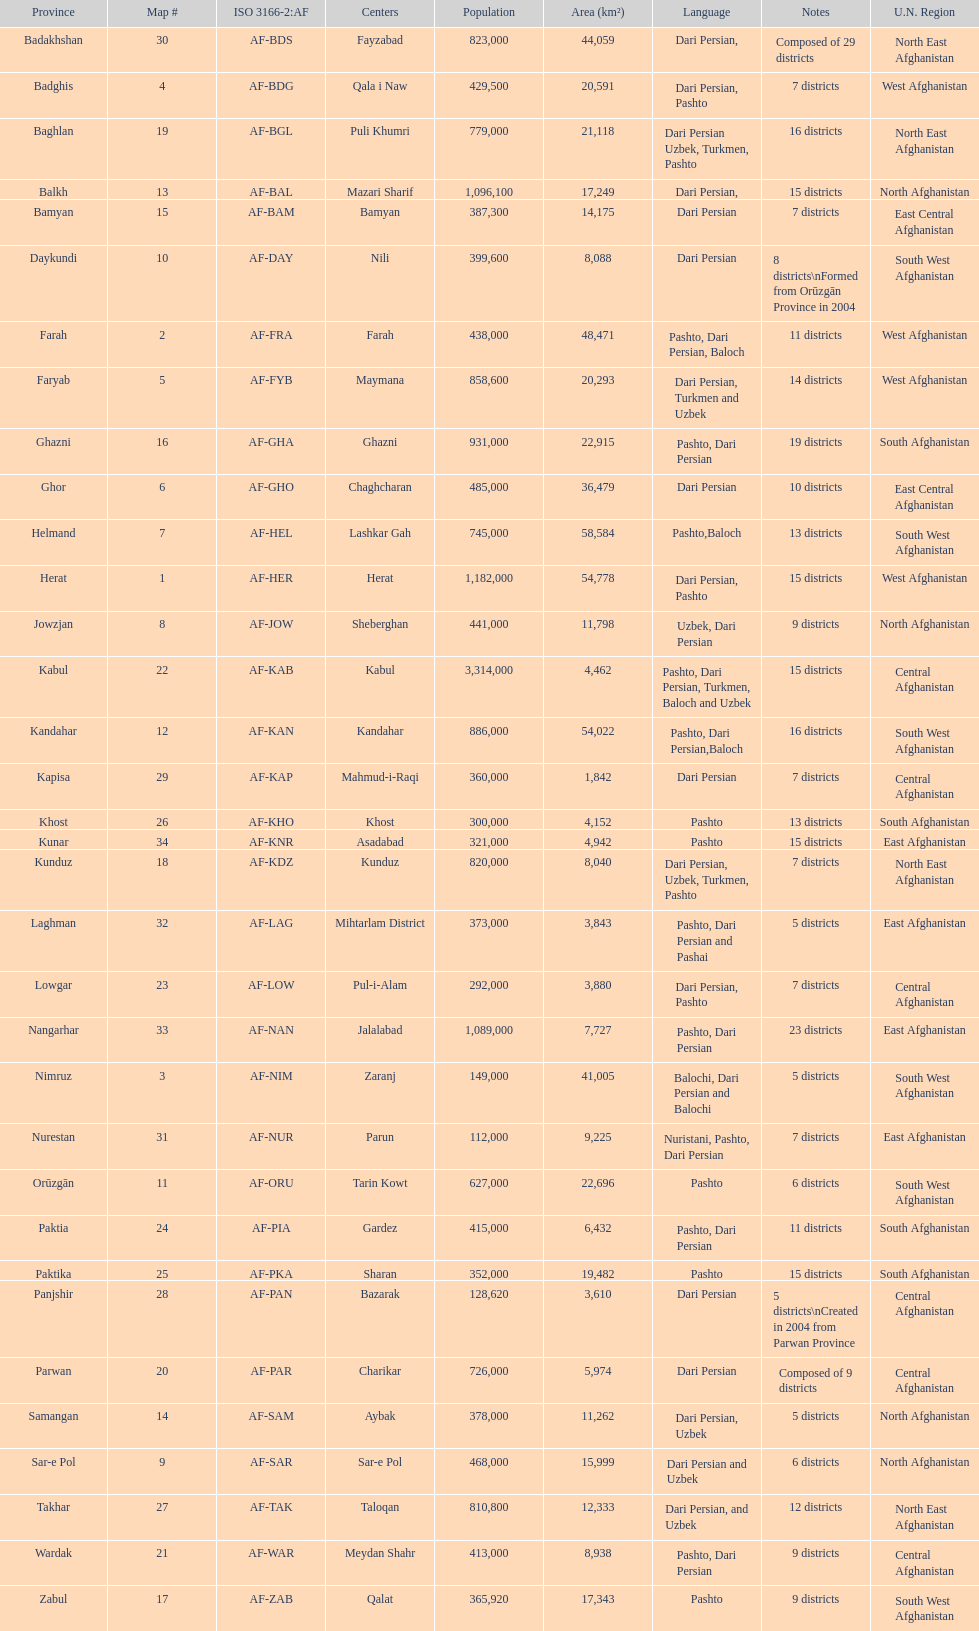How many provinces have the same number of districts as kabul? 4. Parse the table in full. {'header': ['Province', 'Map #', 'ISO 3166-2:AF', 'Centers', 'Population', 'Area (km²)', 'Language', 'Notes', 'U.N. Region'], 'rows': [['Badakhshan', '30', 'AF-BDS', 'Fayzabad', '823,000', '44,059', 'Dari Persian,', 'Composed of 29 districts', 'North East Afghanistan'], ['Badghis', '4', 'AF-BDG', 'Qala i Naw', '429,500', '20,591', 'Dari Persian, Pashto', '7 districts', 'West Afghanistan'], ['Baghlan', '19', 'AF-BGL', 'Puli Khumri', '779,000', '21,118', 'Dari Persian Uzbek, Turkmen, Pashto', '16 districts', 'North East Afghanistan'], ['Balkh', '13', 'AF-BAL', 'Mazari Sharif', '1,096,100', '17,249', 'Dari Persian,', '15 districts', 'North Afghanistan'], ['Bamyan', '15', 'AF-BAM', 'Bamyan', '387,300', '14,175', 'Dari Persian', '7 districts', 'East Central Afghanistan'], ['Daykundi', '10', 'AF-DAY', 'Nili', '399,600', '8,088', 'Dari Persian', '8 districts\\nFormed from Orūzgān Province in 2004', 'South West Afghanistan'], ['Farah', '2', 'AF-FRA', 'Farah', '438,000', '48,471', 'Pashto, Dari Persian, Baloch', '11 districts', 'West Afghanistan'], ['Faryab', '5', 'AF-FYB', 'Maymana', '858,600', '20,293', 'Dari Persian, Turkmen and Uzbek', '14 districts', 'West Afghanistan'], ['Ghazni', '16', 'AF-GHA', 'Ghazni', '931,000', '22,915', 'Pashto, Dari Persian', '19 districts', 'South Afghanistan'], ['Ghor', '6', 'AF-GHO', 'Chaghcharan', '485,000', '36,479', 'Dari Persian', '10 districts', 'East Central Afghanistan'], ['Helmand', '7', 'AF-HEL', 'Lashkar Gah', '745,000', '58,584', 'Pashto,Baloch', '13 districts', 'South West Afghanistan'], ['Herat', '1', 'AF-HER', 'Herat', '1,182,000', '54,778', 'Dari Persian, Pashto', '15 districts', 'West Afghanistan'], ['Jowzjan', '8', 'AF-JOW', 'Sheberghan', '441,000', '11,798', 'Uzbek, Dari Persian', '9 districts', 'North Afghanistan'], ['Kabul', '22', 'AF-KAB', 'Kabul', '3,314,000', '4,462', 'Pashto, Dari Persian, Turkmen, Baloch and Uzbek', '15 districts', 'Central Afghanistan'], ['Kandahar', '12', 'AF-KAN', 'Kandahar', '886,000', '54,022', 'Pashto, Dari Persian,Baloch', '16 districts', 'South West Afghanistan'], ['Kapisa', '29', 'AF-KAP', 'Mahmud-i-Raqi', '360,000', '1,842', 'Dari Persian', '7 districts', 'Central Afghanistan'], ['Khost', '26', 'AF-KHO', 'Khost', '300,000', '4,152', 'Pashto', '13 districts', 'South Afghanistan'], ['Kunar', '34', 'AF-KNR', 'Asadabad', '321,000', '4,942', 'Pashto', '15 districts', 'East Afghanistan'], ['Kunduz', '18', 'AF-KDZ', 'Kunduz', '820,000', '8,040', 'Dari Persian, Uzbek, Turkmen, Pashto', '7 districts', 'North East Afghanistan'], ['Laghman', '32', 'AF-LAG', 'Mihtarlam District', '373,000', '3,843', 'Pashto, Dari Persian and Pashai', '5 districts', 'East Afghanistan'], ['Lowgar', '23', 'AF-LOW', 'Pul-i-Alam', '292,000', '3,880', 'Dari Persian, Pashto', '7 districts', 'Central Afghanistan'], ['Nangarhar', '33', 'AF-NAN', 'Jalalabad', '1,089,000', '7,727', 'Pashto, Dari Persian', '23 districts', 'East Afghanistan'], ['Nimruz', '3', 'AF-NIM', 'Zaranj', '149,000', '41,005', 'Balochi, Dari Persian and Balochi', '5 districts', 'South West Afghanistan'], ['Nurestan', '31', 'AF-NUR', 'Parun', '112,000', '9,225', 'Nuristani, Pashto, Dari Persian', '7 districts', 'East Afghanistan'], ['Orūzgān', '11', 'AF-ORU', 'Tarin Kowt', '627,000', '22,696', 'Pashto', '6 districts', 'South West Afghanistan'], ['Paktia', '24', 'AF-PIA', 'Gardez', '415,000', '6,432', 'Pashto, Dari Persian', '11 districts', 'South Afghanistan'], ['Paktika', '25', 'AF-PKA', 'Sharan', '352,000', '19,482', 'Pashto', '15 districts', 'South Afghanistan'], ['Panjshir', '28', 'AF-PAN', 'Bazarak', '128,620', '3,610', 'Dari Persian', '5 districts\\nCreated in 2004 from Parwan Province', 'Central Afghanistan'], ['Parwan', '20', 'AF-PAR', 'Charikar', '726,000', '5,974', 'Dari Persian', 'Composed of 9 districts', 'Central Afghanistan'], ['Samangan', '14', 'AF-SAM', 'Aybak', '378,000', '11,262', 'Dari Persian, Uzbek', '5 districts', 'North Afghanistan'], ['Sar-e Pol', '9', 'AF-SAR', 'Sar-e Pol', '468,000', '15,999', 'Dari Persian and Uzbek', '6 districts', 'North Afghanistan'], ['Takhar', '27', 'AF-TAK', 'Taloqan', '810,800', '12,333', 'Dari Persian, and Uzbek', '12 districts', 'North East Afghanistan'], ['Wardak', '21', 'AF-WAR', 'Meydan Shahr', '413,000', '8,938', 'Pashto, Dari Persian', '9 districts', 'Central Afghanistan'], ['Zabul', '17', 'AF-ZAB', 'Qalat', '365,920', '17,343', 'Pashto', '9 districts', 'South West Afghanistan']]} 